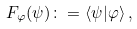Convert formula to latex. <formula><loc_0><loc_0><loc_500><loc_500>F _ { \varphi } ( \psi ) \colon = \langle \psi | \varphi \rangle \, ,</formula> 